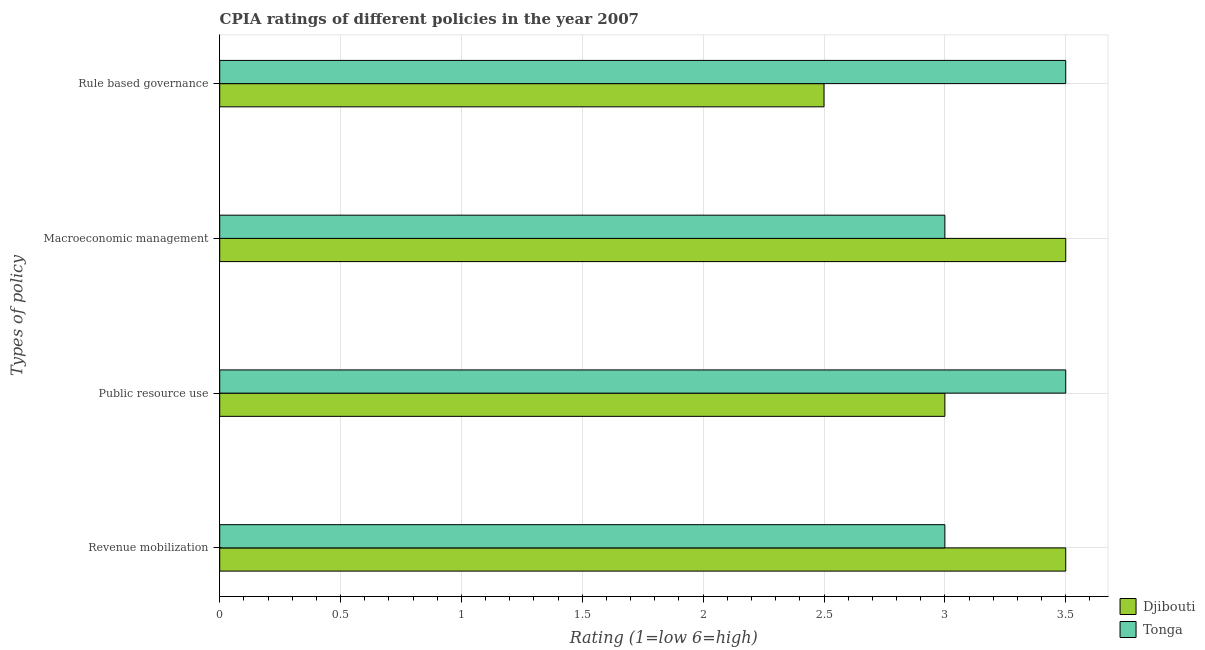How many different coloured bars are there?
Make the answer very short. 2. How many bars are there on the 4th tick from the top?
Your response must be concise. 2. What is the label of the 4th group of bars from the top?
Your answer should be very brief. Revenue mobilization. Across all countries, what is the maximum cpia rating of public resource use?
Your response must be concise. 3.5. Across all countries, what is the minimum cpia rating of rule based governance?
Ensure brevity in your answer.  2.5. In which country was the cpia rating of revenue mobilization maximum?
Offer a terse response. Djibouti. In which country was the cpia rating of rule based governance minimum?
Offer a terse response. Djibouti. What is the difference between the cpia rating of rule based governance in Tonga and the cpia rating of public resource use in Djibouti?
Your answer should be compact. 0.5. What is the average cpia rating of revenue mobilization per country?
Offer a terse response. 3.25. What is the difference between the cpia rating of public resource use and cpia rating of revenue mobilization in Tonga?
Make the answer very short. 0.5. In how many countries, is the cpia rating of macroeconomic management greater than 3.1 ?
Offer a very short reply. 1. What is the ratio of the cpia rating of rule based governance in Tonga to that in Djibouti?
Provide a short and direct response. 1.4. Is the cpia rating of rule based governance in Tonga less than that in Djibouti?
Your response must be concise. No. Is the difference between the cpia rating of rule based governance in Djibouti and Tonga greater than the difference between the cpia rating of macroeconomic management in Djibouti and Tonga?
Ensure brevity in your answer.  No. What is the difference between the highest and the second highest cpia rating of macroeconomic management?
Give a very brief answer. 0.5. Is the sum of the cpia rating of macroeconomic management in Djibouti and Tonga greater than the maximum cpia rating of public resource use across all countries?
Keep it short and to the point. Yes. Is it the case that in every country, the sum of the cpia rating of rule based governance and cpia rating of revenue mobilization is greater than the sum of cpia rating of macroeconomic management and cpia rating of public resource use?
Make the answer very short. No. What does the 2nd bar from the top in Macroeconomic management represents?
Your answer should be very brief. Djibouti. What does the 1st bar from the bottom in Rule based governance represents?
Your answer should be very brief. Djibouti. Are all the bars in the graph horizontal?
Provide a succinct answer. Yes. Are the values on the major ticks of X-axis written in scientific E-notation?
Give a very brief answer. No. Does the graph contain grids?
Give a very brief answer. Yes. Where does the legend appear in the graph?
Provide a succinct answer. Bottom right. What is the title of the graph?
Keep it short and to the point. CPIA ratings of different policies in the year 2007. What is the label or title of the X-axis?
Ensure brevity in your answer.  Rating (1=low 6=high). What is the label or title of the Y-axis?
Your answer should be very brief. Types of policy. What is the Rating (1=low 6=high) of Djibouti in Revenue mobilization?
Keep it short and to the point. 3.5. What is the Rating (1=low 6=high) of Djibouti in Public resource use?
Offer a very short reply. 3. What is the Rating (1=low 6=high) in Tonga in Public resource use?
Provide a short and direct response. 3.5. What is the Rating (1=low 6=high) of Tonga in Rule based governance?
Your response must be concise. 3.5. Across all Types of policy, what is the maximum Rating (1=low 6=high) of Djibouti?
Provide a succinct answer. 3.5. Across all Types of policy, what is the maximum Rating (1=low 6=high) in Tonga?
Make the answer very short. 3.5. Across all Types of policy, what is the minimum Rating (1=low 6=high) in Djibouti?
Your answer should be very brief. 2.5. What is the total Rating (1=low 6=high) in Djibouti in the graph?
Provide a short and direct response. 12.5. What is the difference between the Rating (1=low 6=high) in Djibouti in Revenue mobilization and that in Macroeconomic management?
Offer a very short reply. 0. What is the difference between the Rating (1=low 6=high) in Tonga in Revenue mobilization and that in Macroeconomic management?
Offer a terse response. 0. What is the difference between the Rating (1=low 6=high) of Djibouti in Public resource use and that in Macroeconomic management?
Your answer should be very brief. -0.5. What is the difference between the Rating (1=low 6=high) of Djibouti in Public resource use and that in Rule based governance?
Make the answer very short. 0.5. What is the difference between the Rating (1=low 6=high) in Tonga in Macroeconomic management and that in Rule based governance?
Provide a short and direct response. -0.5. What is the difference between the Rating (1=low 6=high) of Djibouti in Revenue mobilization and the Rating (1=low 6=high) of Tonga in Public resource use?
Your response must be concise. 0. What is the difference between the Rating (1=low 6=high) in Djibouti in Public resource use and the Rating (1=low 6=high) in Tonga in Rule based governance?
Your answer should be very brief. -0.5. What is the average Rating (1=low 6=high) in Djibouti per Types of policy?
Provide a short and direct response. 3.12. What is the average Rating (1=low 6=high) in Tonga per Types of policy?
Provide a succinct answer. 3.25. What is the difference between the Rating (1=low 6=high) in Djibouti and Rating (1=low 6=high) in Tonga in Revenue mobilization?
Your answer should be compact. 0.5. What is the ratio of the Rating (1=low 6=high) of Djibouti in Revenue mobilization to that in Public resource use?
Offer a very short reply. 1.17. What is the ratio of the Rating (1=low 6=high) of Tonga in Revenue mobilization to that in Public resource use?
Keep it short and to the point. 0.86. What is the ratio of the Rating (1=low 6=high) of Djibouti in Revenue mobilization to that in Macroeconomic management?
Your answer should be compact. 1. What is the ratio of the Rating (1=low 6=high) of Tonga in Revenue mobilization to that in Macroeconomic management?
Keep it short and to the point. 1. What is the ratio of the Rating (1=low 6=high) in Djibouti in Revenue mobilization to that in Rule based governance?
Your response must be concise. 1.4. What is the ratio of the Rating (1=low 6=high) of Djibouti in Public resource use to that in Macroeconomic management?
Keep it short and to the point. 0.86. What is the ratio of the Rating (1=low 6=high) in Djibouti in Public resource use to that in Rule based governance?
Ensure brevity in your answer.  1.2. What is the ratio of the Rating (1=low 6=high) in Tonga in Public resource use to that in Rule based governance?
Offer a very short reply. 1. What is the ratio of the Rating (1=low 6=high) in Djibouti in Macroeconomic management to that in Rule based governance?
Offer a terse response. 1.4. What is the difference between the highest and the second highest Rating (1=low 6=high) of Djibouti?
Ensure brevity in your answer.  0. What is the difference between the highest and the second highest Rating (1=low 6=high) of Tonga?
Provide a succinct answer. 0. 